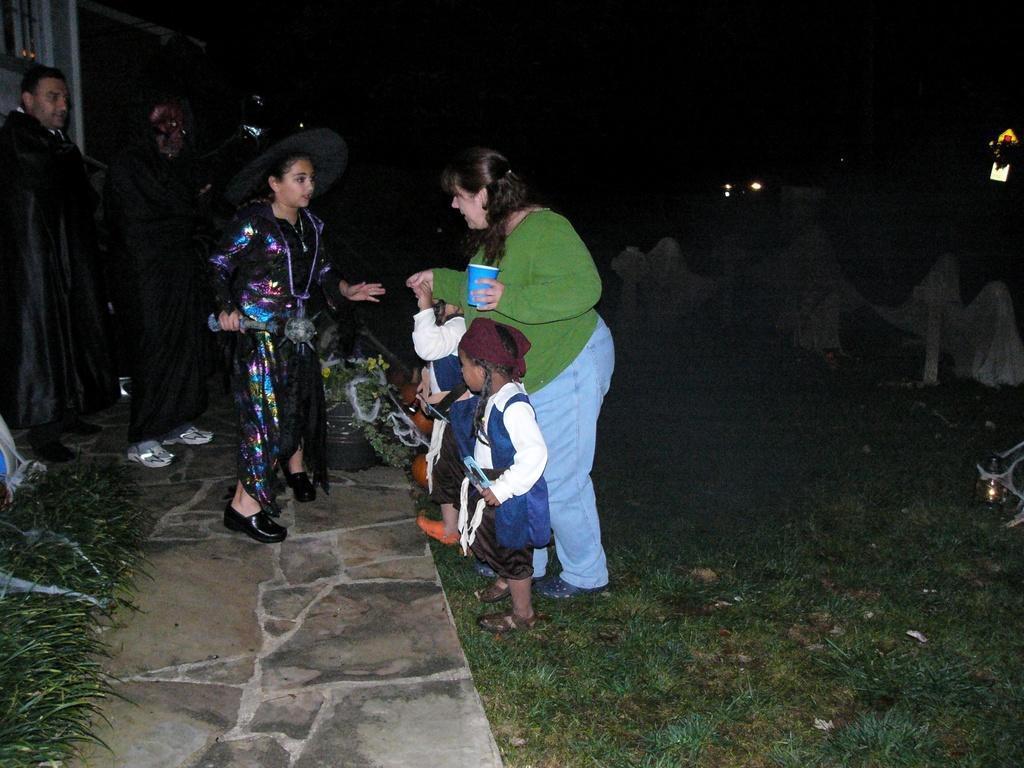How would you summarize this image in a sentence or two? This image consists of some persons in the middle. There are girls, women and men. There is grass at the bottom. 